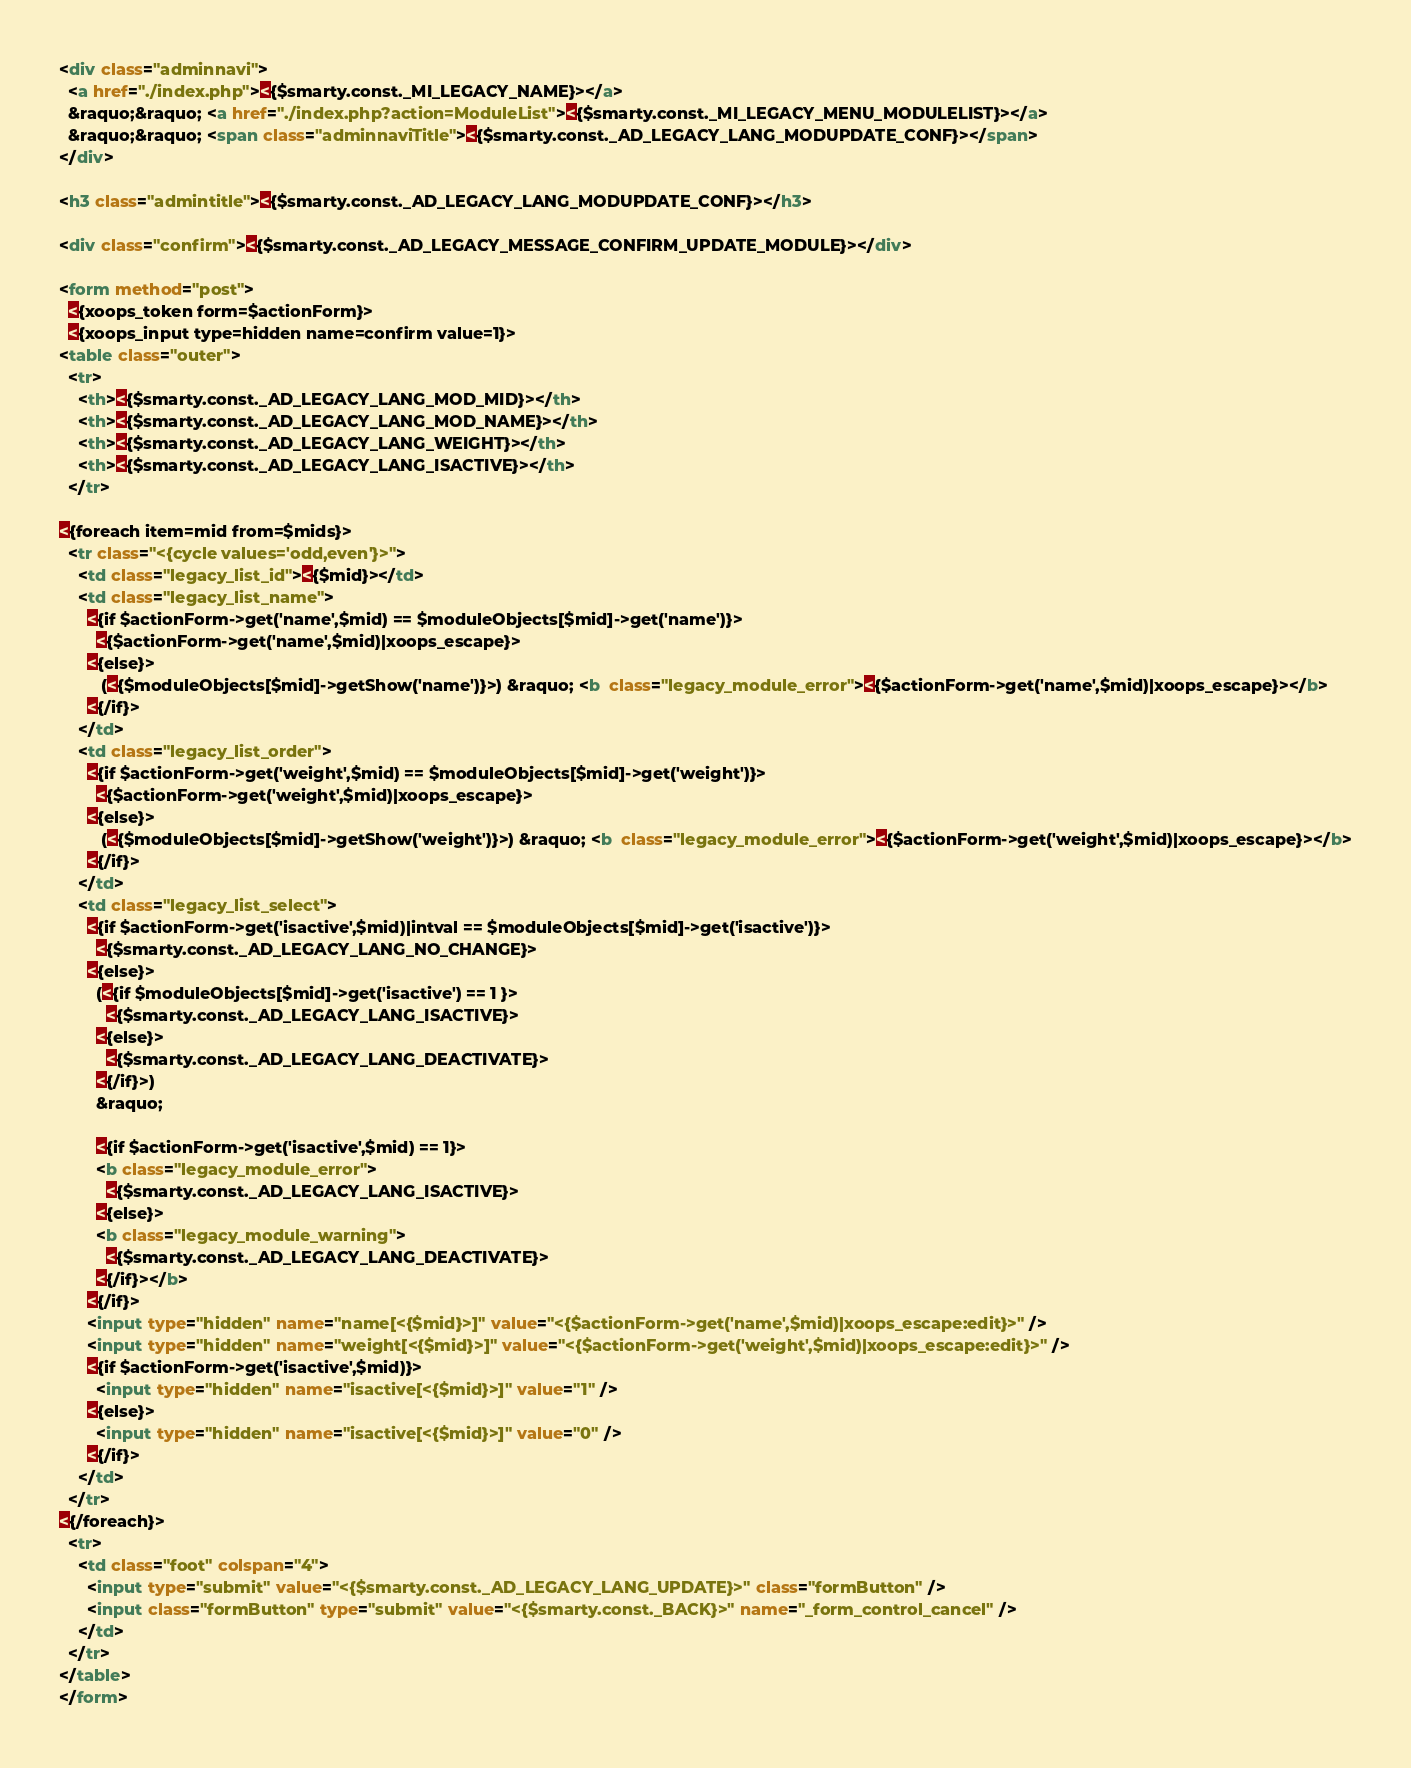Convert code to text. <code><loc_0><loc_0><loc_500><loc_500><_HTML_><div class="adminnavi">
  <a href="./index.php"><{$smarty.const._MI_LEGACY_NAME}></a>
  &raquo;&raquo; <a href="./index.php?action=ModuleList"><{$smarty.const._MI_LEGACY_MENU_MODULELIST}></a>
  &raquo;&raquo; <span class="adminnaviTitle"><{$smarty.const._AD_LEGACY_LANG_MODUPDATE_CONF}></span>
</div>

<h3 class="admintitle"><{$smarty.const._AD_LEGACY_LANG_MODUPDATE_CONF}></h3>

<div class="confirm"><{$smarty.const._AD_LEGACY_MESSAGE_CONFIRM_UPDATE_MODULE}></div>

<form method="post">
  <{xoops_token form=$actionForm}>
  <{xoops_input type=hidden name=confirm value=1}>
<table class="outer">
  <tr>
    <th><{$smarty.const._AD_LEGACY_LANG_MOD_MID}></th>
    <th><{$smarty.const._AD_LEGACY_LANG_MOD_NAME}></th>
    <th><{$smarty.const._AD_LEGACY_LANG_WEIGHT}></th>
    <th><{$smarty.const._AD_LEGACY_LANG_ISACTIVE}></th>
  </tr>

<{foreach item=mid from=$mids}>
  <tr class="<{cycle values='odd,even'}>">
    <td class="legacy_list_id"><{$mid}></td>
    <td class="legacy_list_name">
      <{if $actionForm->get('name',$mid) == $moduleObjects[$mid]->get('name')}>
        <{$actionForm->get('name',$mid)|xoops_escape}>
      <{else}>
         (<{$moduleObjects[$mid]->getShow('name')}>) &raquo; <b  class="legacy_module_error"><{$actionForm->get('name',$mid)|xoops_escape}></b>
      <{/if}>
    </td>
    <td class="legacy_list_order">
      <{if $actionForm->get('weight',$mid) == $moduleObjects[$mid]->get('weight')}>
        <{$actionForm->get('weight',$mid)|xoops_escape}>
      <{else}>
         (<{$moduleObjects[$mid]->getShow('weight')}>) &raquo; <b  class="legacy_module_error"><{$actionForm->get('weight',$mid)|xoops_escape}></b>
      <{/if}>
    </td>
    <td class="legacy_list_select">
      <{if $actionForm->get('isactive',$mid)|intval == $moduleObjects[$mid]->get('isactive')}>
        <{$smarty.const._AD_LEGACY_LANG_NO_CHANGE}>
      <{else}>
        (<{if $moduleObjects[$mid]->get('isactive') == 1 }>
          <{$smarty.const._AD_LEGACY_LANG_ISACTIVE}>
        <{else}>
          <{$smarty.const._AD_LEGACY_LANG_DEACTIVATE}>
        <{/if}>) 
        &raquo;
        
        <{if $actionForm->get('isactive',$mid) == 1}>
        <b class="legacy_module_error">
          <{$smarty.const._AD_LEGACY_LANG_ISACTIVE}>
        <{else}>
        <b class="legacy_module_warning">
          <{$smarty.const._AD_LEGACY_LANG_DEACTIVATE}>
        <{/if}></b>
      <{/if}>
      <input type="hidden" name="name[<{$mid}>]" value="<{$actionForm->get('name',$mid)|xoops_escape:edit}>" />
      <input type="hidden" name="weight[<{$mid}>]" value="<{$actionForm->get('weight',$mid)|xoops_escape:edit}>" />
      <{if $actionForm->get('isactive',$mid)}>
        <input type="hidden" name="isactive[<{$mid}>]" value="1" />
      <{else}>
        <input type="hidden" name="isactive[<{$mid}>]" value="0" />
      <{/if}>
    </td>
  </tr>
<{/foreach}>
  <tr>
    <td class="foot" colspan="4">
      <input type="submit" value="<{$smarty.const._AD_LEGACY_LANG_UPDATE}>" class="formButton" />
      <input class="formButton" type="submit" value="<{$smarty.const._BACK}>" name="_form_control_cancel" />
    </td>
  </tr>
</table>
</form>
</code> 